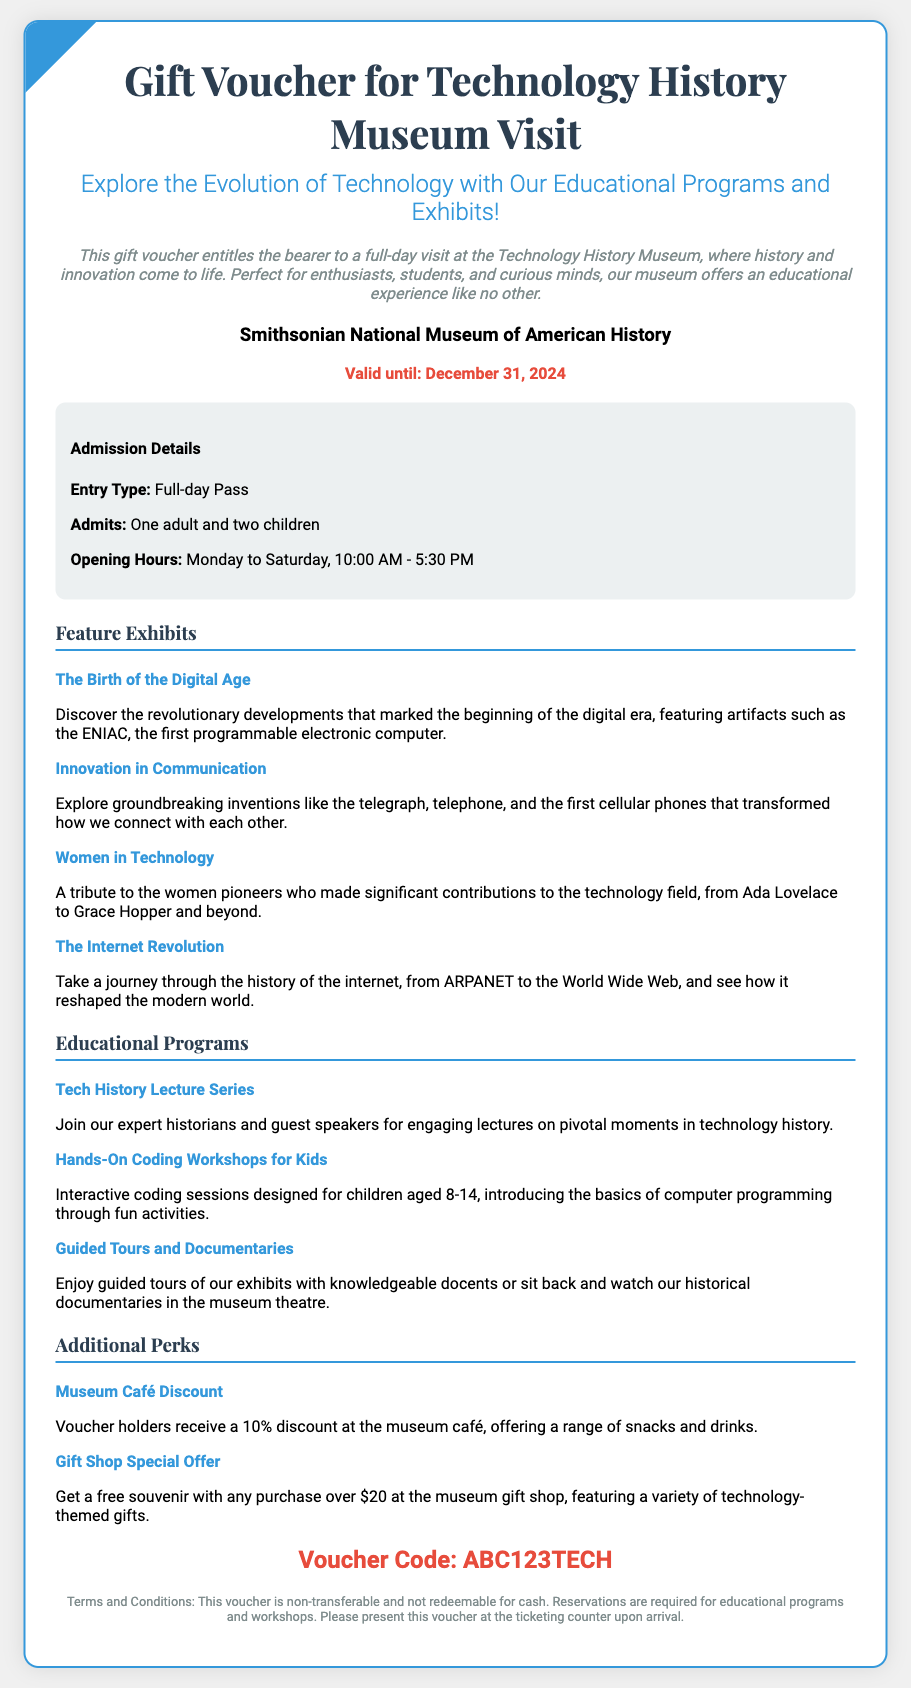What is the name of the museum? The document states that the voucher is for the Smithsonian National Museum of American History.
Answer: Smithsonian National Museum of American History What is the validity period of the voucher? The voucher mentions that it is valid until December 31, 2024.
Answer: December 31, 2024 How many children does the voucher admit? The admission details indicate that the voucher admits two children.
Answer: Two children What is one feature exhibit mentioned in the document? The document lists several feature exhibits, including "The Birth of the Digital Age."
Answer: The Birth of the Digital Age What age group is targeted by the Hands-On Coding Workshops? The educational program specifies that the workshops are for children aged 8-14.
Answer: 8-14 What type of pass does the voucher provide? The document specifies that the entry type is a Full-day Pass.
Answer: Full-day Pass What discount do voucher holders receive at the museum café? The additional perks indicate that voucher holders receive a 10% discount.
Answer: 10% Is the voucher transferable? The terms and conditions clearly state that this voucher is non-transferable.
Answer: Non-transferable What is the voucher code? The document provides a specific voucher code: ABC123TECH.
Answer: ABC123TECH 